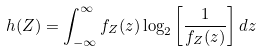<formula> <loc_0><loc_0><loc_500><loc_500>h ( Z ) = \int _ { - \infty } ^ { \infty } f _ { Z } ( z ) \log _ { 2 } \left [ \frac { 1 } { f _ { Z } ( z ) } \right ] d z</formula> 